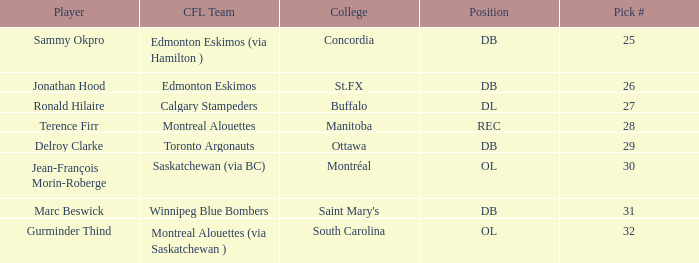Which institution has an ol position with a pick # exceeding 30? South Carolina. 